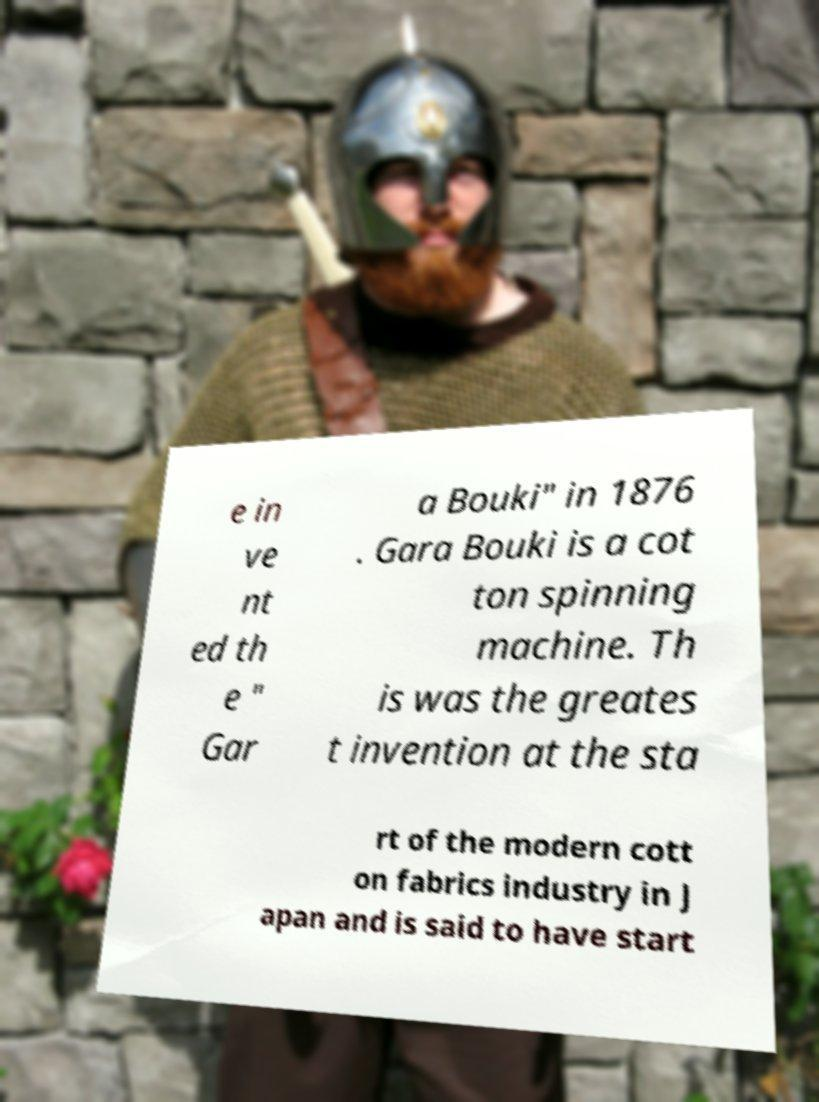What messages or text are displayed in this image? I need them in a readable, typed format. e in ve nt ed th e " Gar a Bouki" in 1876 . Gara Bouki is a cot ton spinning machine. Th is was the greates t invention at the sta rt of the modern cott on fabrics industry in J apan and is said to have start 